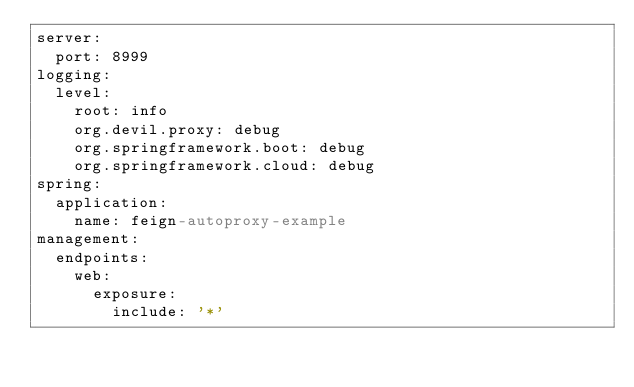<code> <loc_0><loc_0><loc_500><loc_500><_YAML_>server:
  port: 8999
logging:
  level:
    root: info
    org.devil.proxy: debug
    org.springframework.boot: debug
    org.springframework.cloud: debug
spring:
  application:
    name: feign-autoproxy-example
management:
  endpoints:
    web:
      exposure:
        include: '*'
</code> 